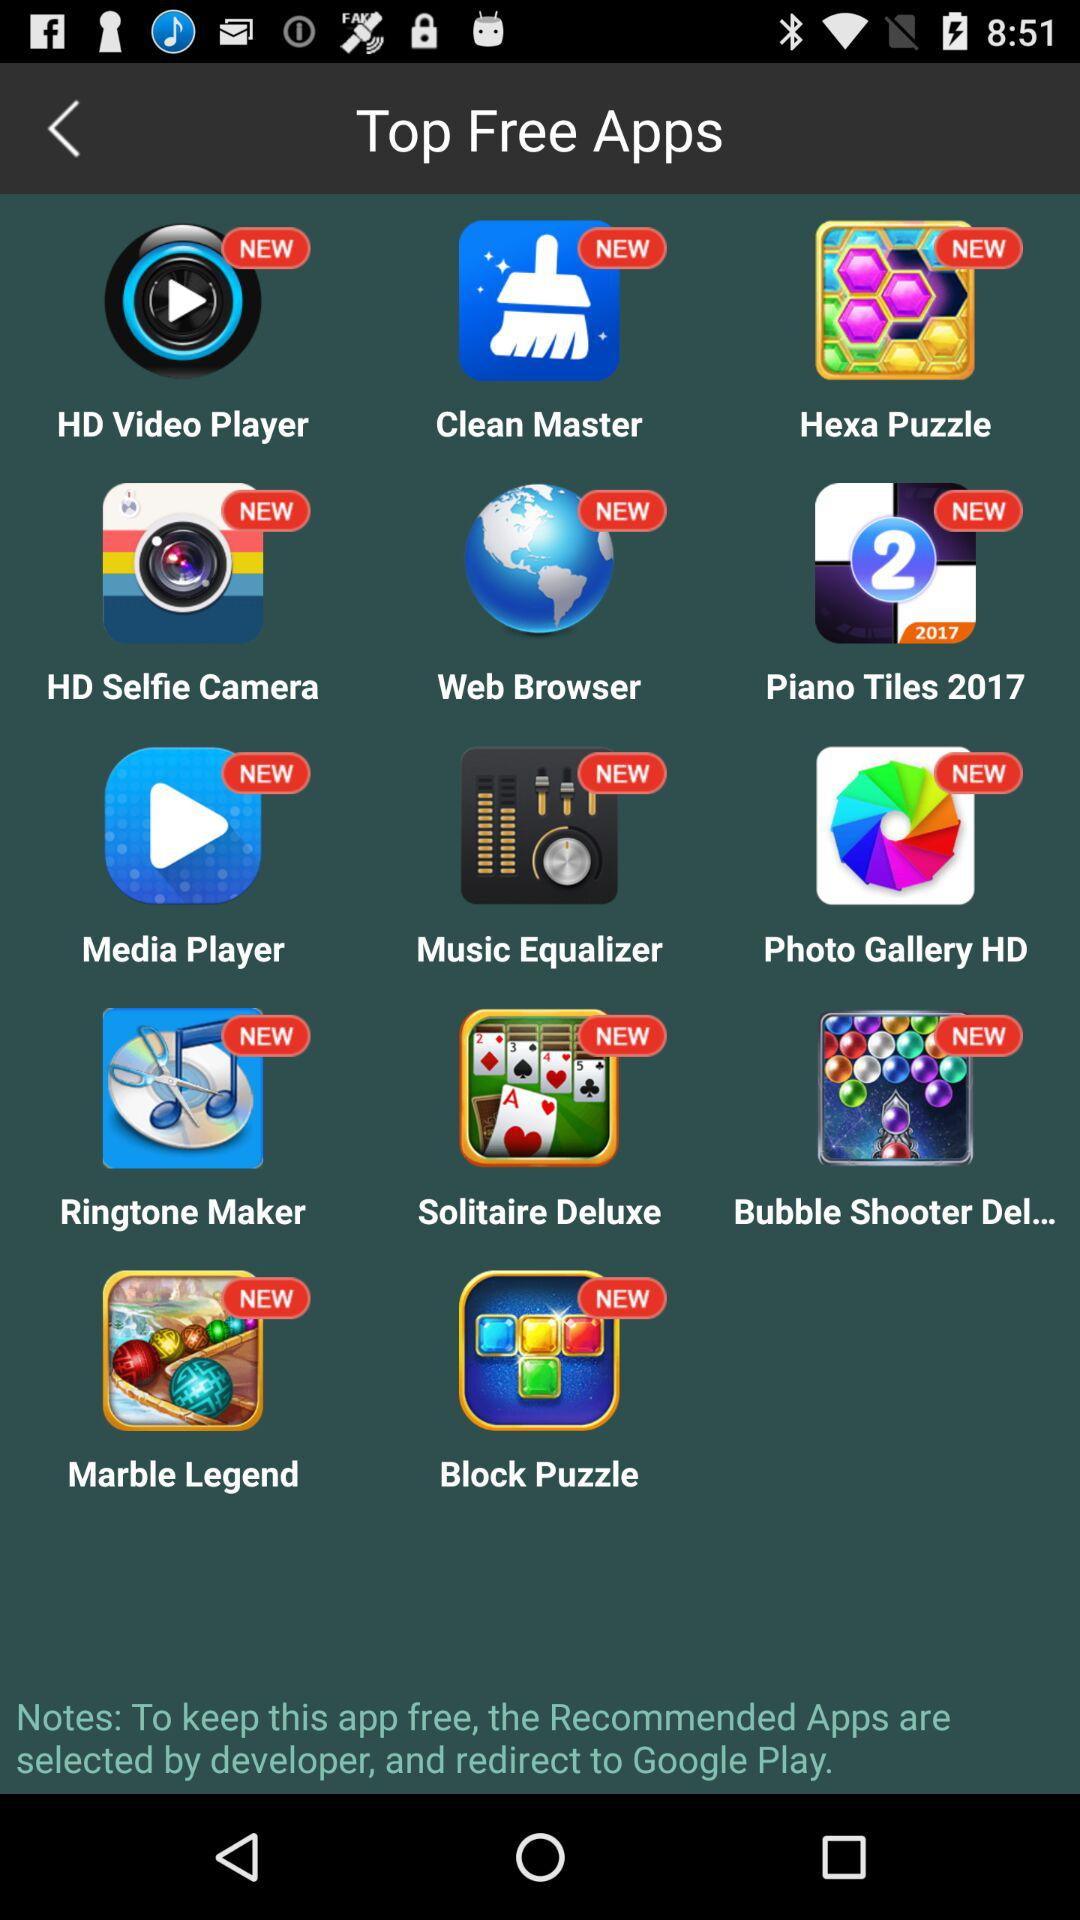Which browser app is free? The free browser app is "Web Browser". 